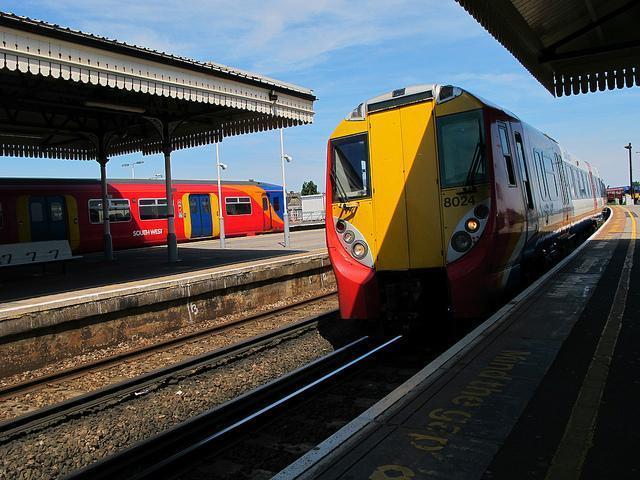How many trains on the track?
Give a very brief answer. 2. How many trains are in the photo?
Give a very brief answer. 2. How many trains are there?
Give a very brief answer. 2. How many people are wearing red shirt?
Give a very brief answer. 0. 